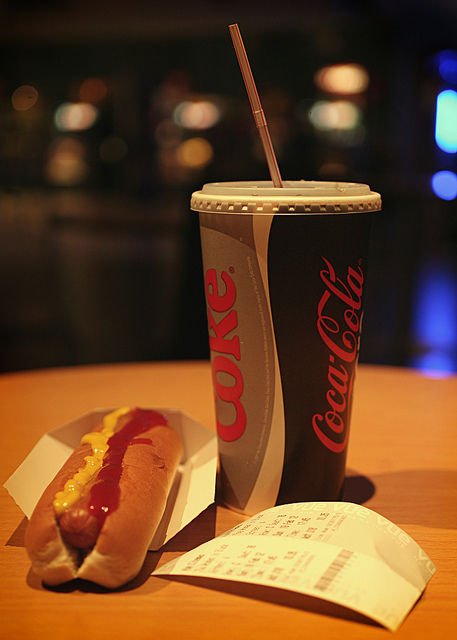Extract all visible text content from this image. Coca-Cola Coke 